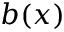<formula> <loc_0><loc_0><loc_500><loc_500>b ( x )</formula> 